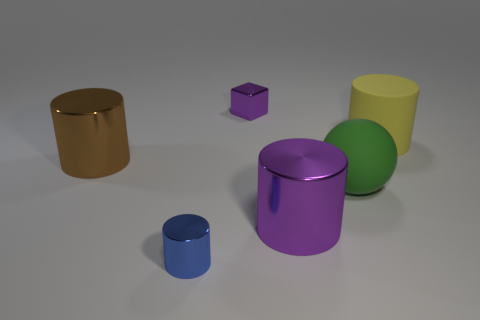Is the size of the green thing the same as the brown cylinder?
Your answer should be compact. Yes. What number of things are either big matte cylinders or large green matte balls?
Your response must be concise. 2. There is a small object left of the tiny object that is behind the cylinder right of the ball; what shape is it?
Provide a short and direct response. Cylinder. Are the small thing in front of the big brown shiny cylinder and the big thing right of the green rubber thing made of the same material?
Your response must be concise. No. There is a purple thing that is the same shape as the tiny blue thing; what is it made of?
Your answer should be very brief. Metal. There is a metallic thing on the right side of the tiny purple shiny thing; is it the same shape as the purple shiny thing behind the yellow matte cylinder?
Keep it short and to the point. No. Is the number of yellow rubber cylinders that are left of the brown metal thing less than the number of tiny metal cylinders in front of the block?
Provide a succinct answer. Yes. How many other things are the same shape as the small purple object?
Provide a succinct answer. 0. The purple thing that is the same material as the block is what shape?
Give a very brief answer. Cylinder. What color is the metallic cylinder that is behind the small blue metallic object and to the left of the big purple shiny object?
Offer a very short reply. Brown. 